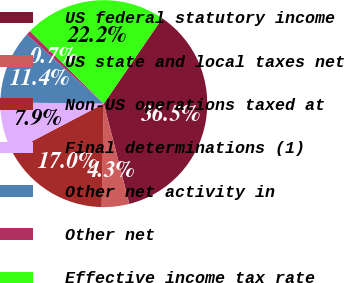<chart> <loc_0><loc_0><loc_500><loc_500><pie_chart><fcel>US federal statutory income<fcel>US state and local taxes net<fcel>Non-US operations taxed at<fcel>Final determinations (1)<fcel>Other net activity in<fcel>Other net<fcel>Effective income tax rate<nl><fcel>36.47%<fcel>4.3%<fcel>16.98%<fcel>7.88%<fcel>11.45%<fcel>0.73%<fcel>22.19%<nl></chart> 